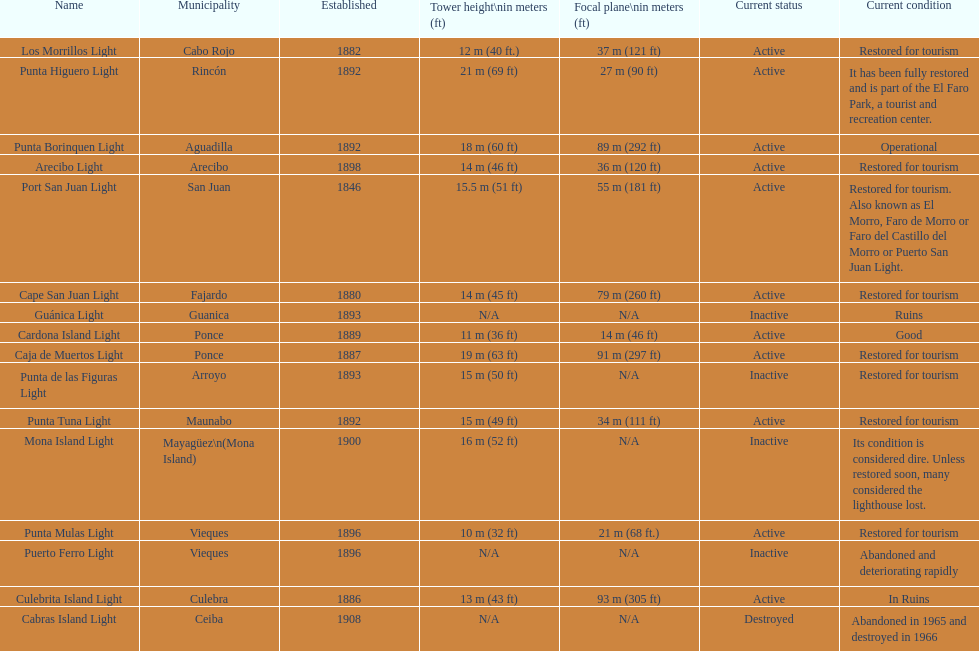Which town was the first to be founded? San Juan. 